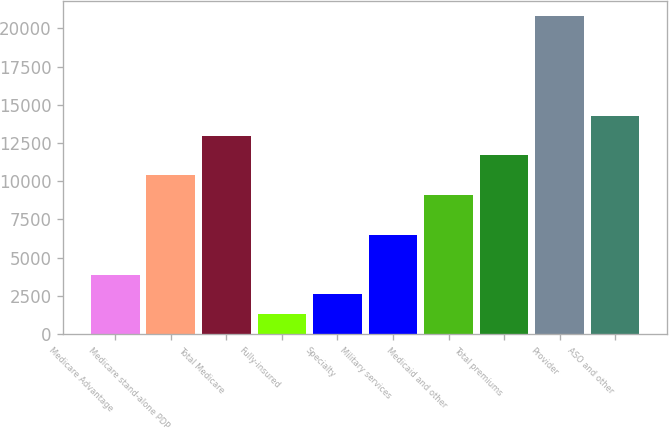<chart> <loc_0><loc_0><loc_500><loc_500><bar_chart><fcel>Medicare Advantage<fcel>Medicare stand-alone PDP<fcel>Total Medicare<fcel>Fully-insured<fcel>Specialty<fcel>Military services<fcel>Medicaid and other<fcel>Total premiums<fcel>Provider<fcel>ASO and other<nl><fcel>3896.62<fcel>10390.5<fcel>12988<fcel>1299.08<fcel>2597.85<fcel>6494.16<fcel>9091.7<fcel>11689.2<fcel>20780.6<fcel>14286.8<nl></chart> 